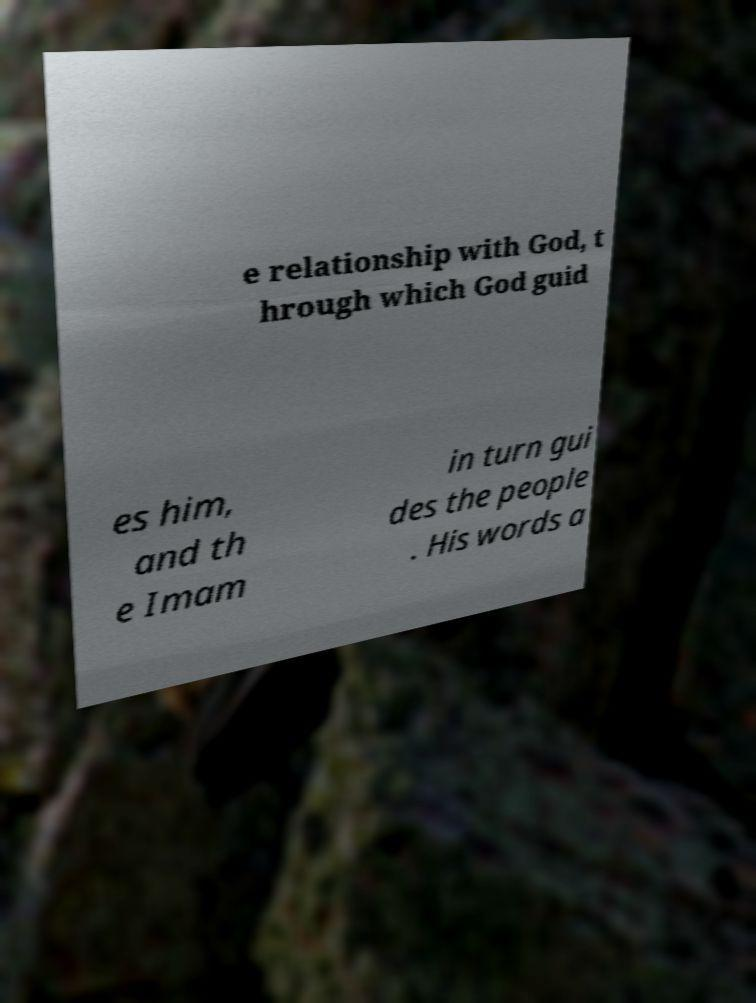Could you assist in decoding the text presented in this image and type it out clearly? e relationship with God, t hrough which God guid es him, and th e Imam in turn gui des the people . His words a 